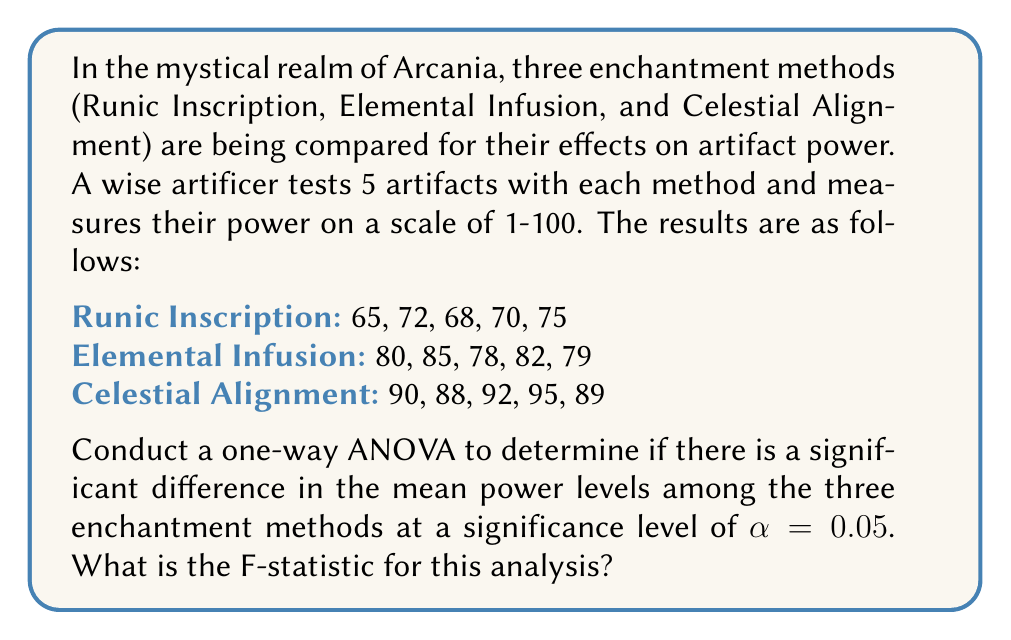Give your solution to this math problem. Let us embark on this magical journey of statistical analysis, guided by the wisdom of the ages:

1) First, we calculate the sum of squares:

   Total Sum of Squares (SST):
   $$ SST = \sum_{i=1}^{n} (x_i - \overline{x})^2 $$
   where $x_i$ are all individual observations and $\overline{x}$ is the grand mean.

   Between Group Sum of Squares (SSB):
   $$ SSB = \sum_{i=1}^{k} n_i(\overline{x_i} - \overline{x})^2 $$
   where $k$ is the number of groups, $n_i$ is the number of observations in each group, and $\overline{x_i}$ is the mean of each group.

   Within Group Sum of Squares (SSW):
   $$ SSW = SST - SSB $$

2) Calculate the grand mean:
   $\overline{x} = (65+72+68+70+75+80+85+78+82+79+90+88+92+95+89) / 15 = 80.53$

3) Calculate group means:
   $\overline{x_1} = 70$ (Runic Inscription)
   $\overline{x_2} = 80.8$ (Elemental Infusion)
   $\overline{x_3} = 90.8$ (Celestial Alignment)

4) Calculate SSB:
   $SSB = 5(70-80.53)^2 + 5(80.8-80.53)^2 + 5(90.8-80.53)^2 = 1320.13$

5) Calculate SST:
   $SST = (65-80.53)^2 + (72-80.53)^2 + ... + (89-80.53)^2 = 1608.93$

6) Calculate SSW:
   $SSW = SST - SSB = 1608.93 - 1320.13 = 288.80$

7) Calculate degrees of freedom:
   $df_{between} = k - 1 = 3 - 1 = 2$
   $df_{within} = N - k = 15 - 3 = 12$
   where $N$ is the total number of observations.

8) Calculate Mean Square Between (MSB) and Mean Square Within (MSW):
   $MSB = SSB / df_{between} = 1320.13 / 2 = 660.07$
   $MSW = SSW / df_{within} = 288.80 / 12 = 24.07$

9) Calculate the F-statistic:
   $$ F = \frac{MSB}{MSW} = \frac{660.07}{24.07} = 27.42 $$

Thus, the F-statistic for this analysis is 27.42.
Answer: $F = 27.42$ 